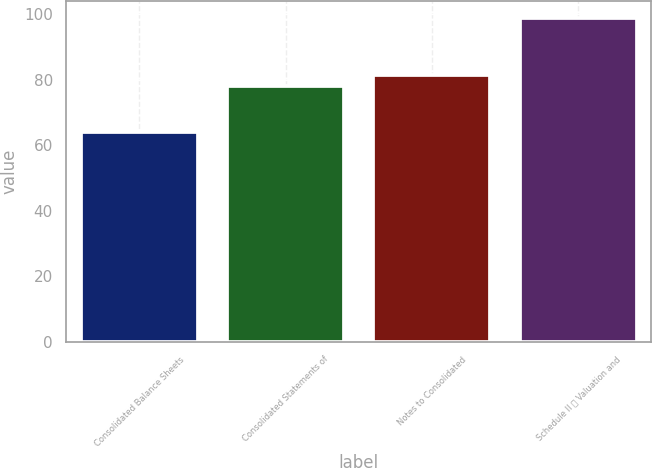Convert chart to OTSL. <chart><loc_0><loc_0><loc_500><loc_500><bar_chart><fcel>Consolidated Balance Sheets<fcel>Consolidated Statements of<fcel>Notes to Consolidated<fcel>Schedule II  Valuation and<nl><fcel>64<fcel>78<fcel>81.5<fcel>99<nl></chart> 